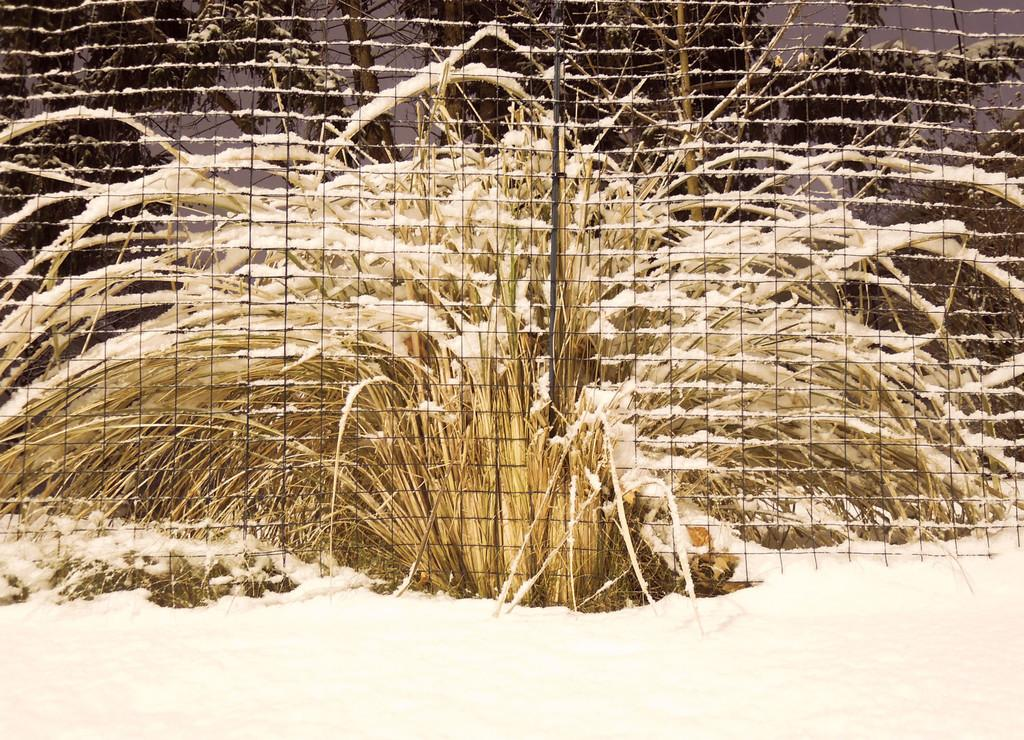What type of vegetation is in the middle of the image? There is grass in the middle of the image. What is located in front of the grass? There is a metal fence in front of the grass. What is the condition of the grass in the image? The grass has snow on it. What mark does the grass receive for its digestion in the image? There is no mark or evaluation of the grass's digestion in the image, as grass does not have a digestive system. 